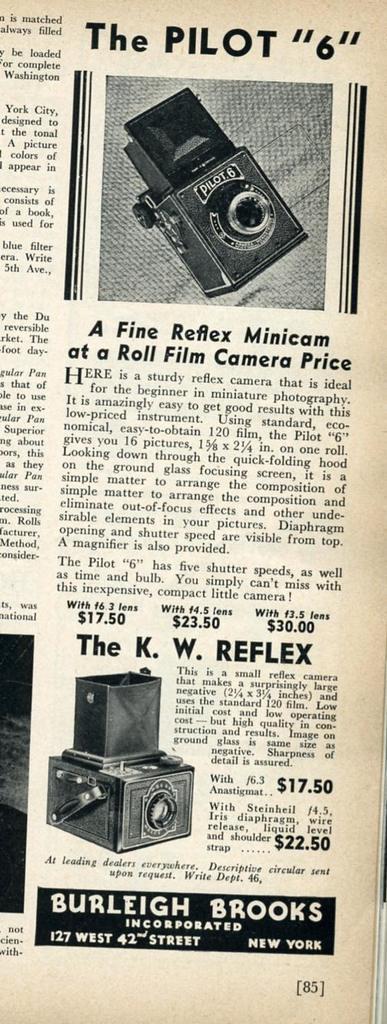Please provide a concise description of this image. In this picture I can see a newspaper on which I can see some pictures of object and something written on it. This picture is black and white in color. 